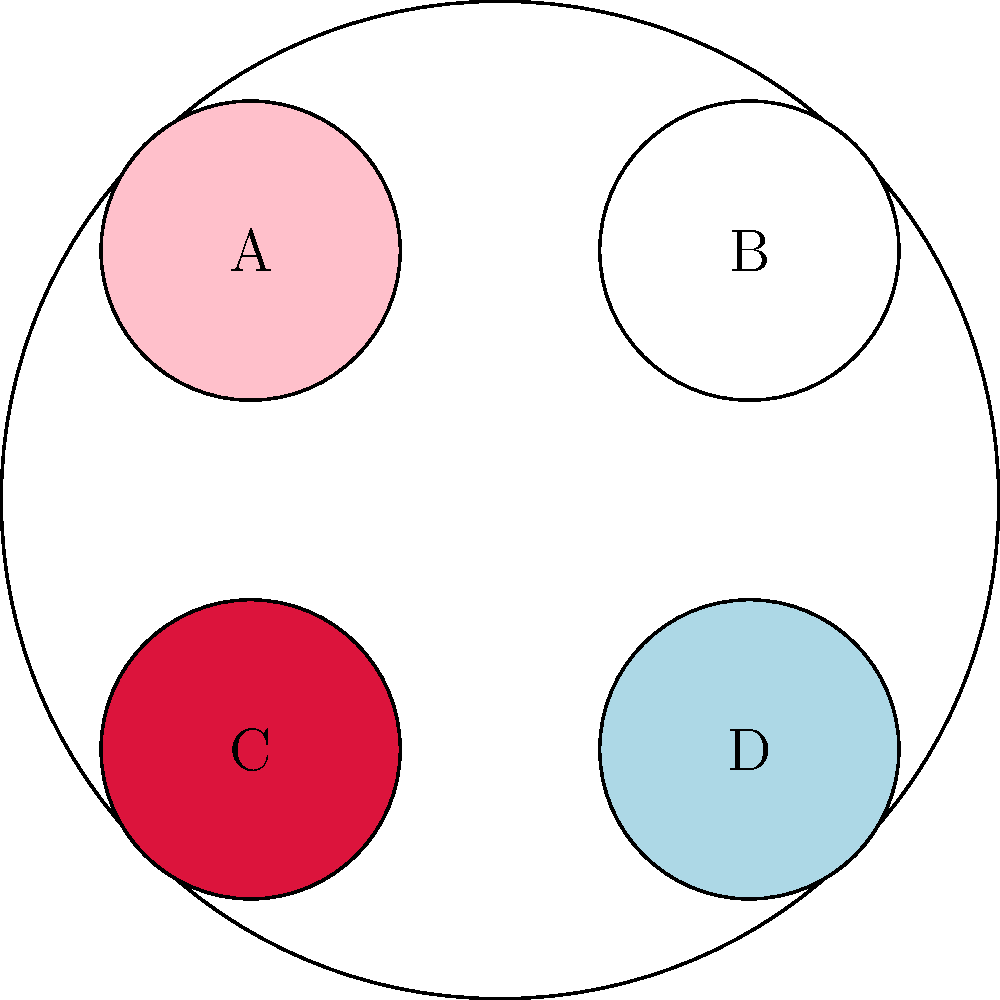Which color combination in the bridal bouquet symbolizes love, purity, and tranquility? To answer this question, we need to analyze the colors presented in the image and their traditional meanings in wedding bouquets:

1. Color A (Light Pink): Represents romance, grace, and femininity.
2. Color B (White): Symbolizes purity, innocence, and new beginnings.
3. Color C (Red): Signifies love, passion, and strong emotions.
4. Color D (Light Blue): Represents tranquility, calmness, and serenity.

Now, let's consider the combination that best fits the description:

1. Love is traditionally represented by red (Color C).
2. Purity is symbolized by white (Color B).
3. Tranquility is associated with light blue (Color D).

Therefore, the combination of colors C (Red), B (White), and D (Light Blue) best symbolizes love, purity, and tranquility in a bridal bouquet.
Answer: C, B, and D 